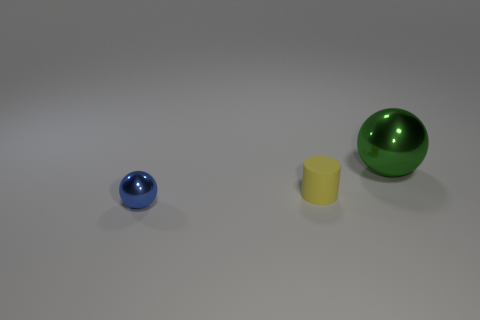Does the small ball have the same color as the small cylinder in front of the big sphere?
Make the answer very short. No. How many other things are the same size as the green sphere?
Your response must be concise. 0. How many blocks are yellow rubber things or large green shiny things?
Offer a terse response. 0. There is a shiny object in front of the yellow cylinder; is it the same shape as the yellow thing?
Your response must be concise. No. Is the number of cylinders that are behind the large metallic thing greater than the number of big balls?
Offer a very short reply. No. What color is the metal ball that is the same size as the yellow matte cylinder?
Give a very brief answer. Blue. What number of things are either balls that are on the left side of the tiny yellow rubber cylinder or large metal cylinders?
Offer a terse response. 1. What material is the small thing that is behind the sphere that is in front of the small rubber cylinder made of?
Provide a short and direct response. Rubber. Is there a large green object that has the same material as the small blue sphere?
Make the answer very short. Yes. There is a metallic sphere that is left of the big ball; are there any large green metallic spheres to the left of it?
Your answer should be very brief. No. 